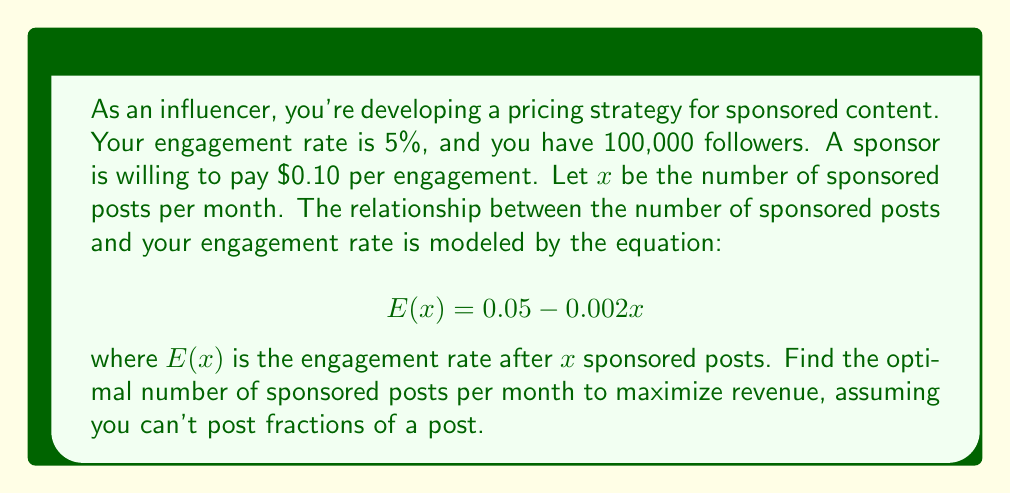Give your solution to this math problem. 1) First, let's create a revenue function. Revenue is the product of:
   - Number of followers
   - Engagement rate
   - Price per engagement
   - Number of posts

   $$R(x) = 100000 \cdot E(x) \cdot 0.10 \cdot x$$

2) Substitute the engagement rate function:

   $$R(x) = 100000 \cdot (0.05 - 0.002x) \cdot 0.10 \cdot x$$

3) Simplify:

   $$R(x) = 500x - 20x^2$$

4) To find the maximum, we need to find the derivative and set it to zero:

   $$\frac{dR}{dx} = 500 - 40x$$

5) Set the derivative to zero and solve:

   $$500 - 40x = 0$$
   $$40x = 500$$
   $$x = 12.5$$

6) The second derivative is negative ($-40$), confirming this is a maximum.

7) Since we can't post fractions of a post, we need to check the revenue for both 12 and 13 posts:

   $$R(12) = 500(12) - 20(12^2) = 3120$$
   $$R(13) = 500(13) - 20(13^2) = 3115$$

8) Therefore, the optimal number of posts is 12.
Answer: 12 posts per month 